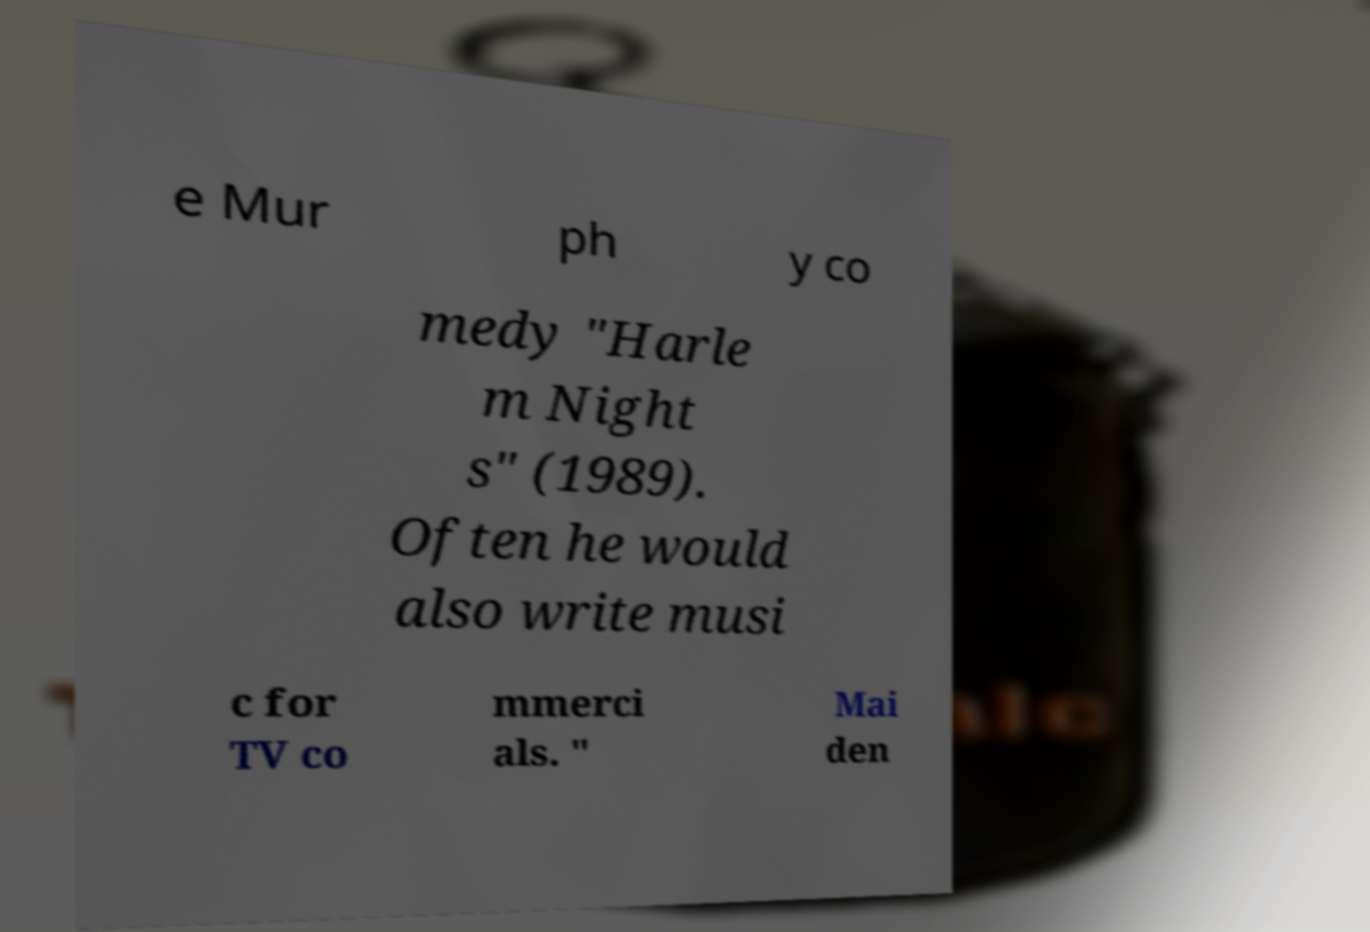Can you read and provide the text displayed in the image?This photo seems to have some interesting text. Can you extract and type it out for me? e Mur ph y co medy "Harle m Night s" (1989). Often he would also write musi c for TV co mmerci als. " Mai den 